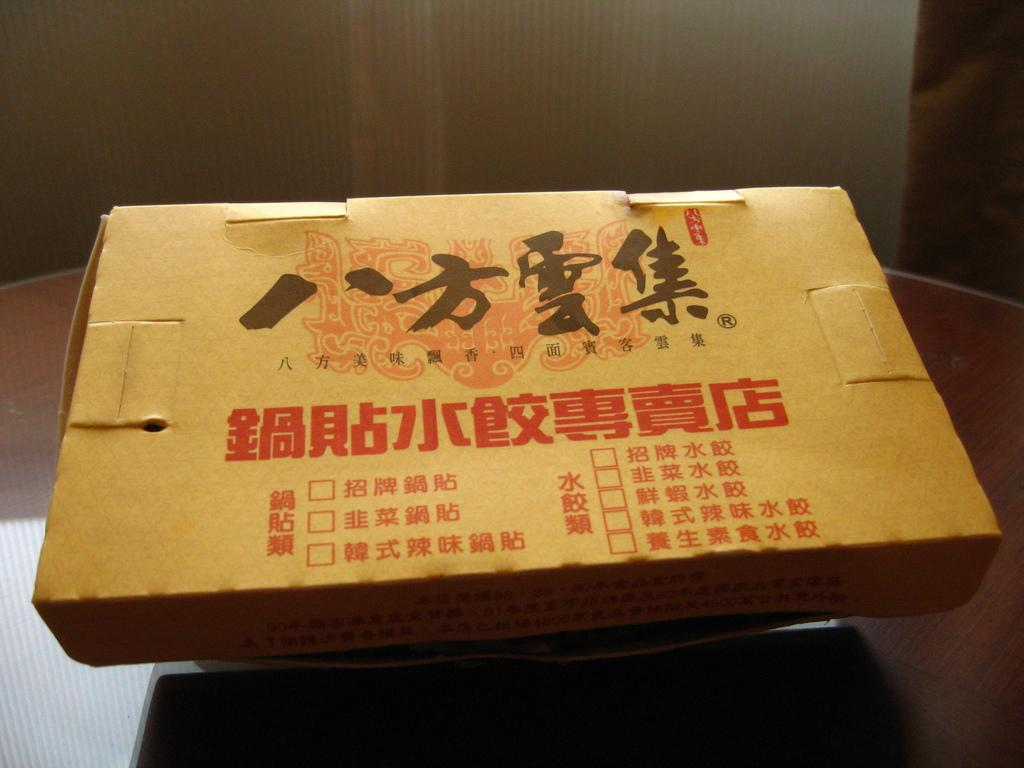What is located on the table in the image? There is a box on a table in the image. Where is the table positioned in the image? The table is in the center of the image. What can be seen on the surface of the box? There are prints on the box. What type of ring is visible on the neck of the person in the image? There is no person or ring present in the image; it only features a box on a table with prints on its surface. 